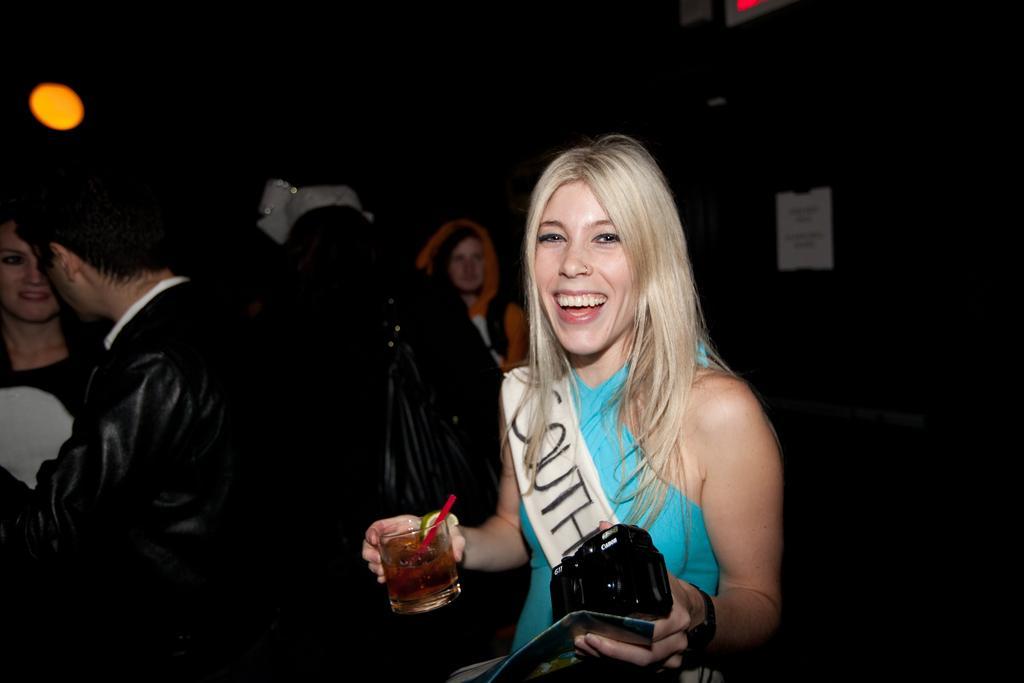Could you give a brief overview of what you see in this image? This image is taken in a room. There are few people in this room. In the middle of this image there is a woman holding a glass with wine in one hand and in other hand she is holding a camera with a smiling face. In the left side of the image there is a man and woman standing. 